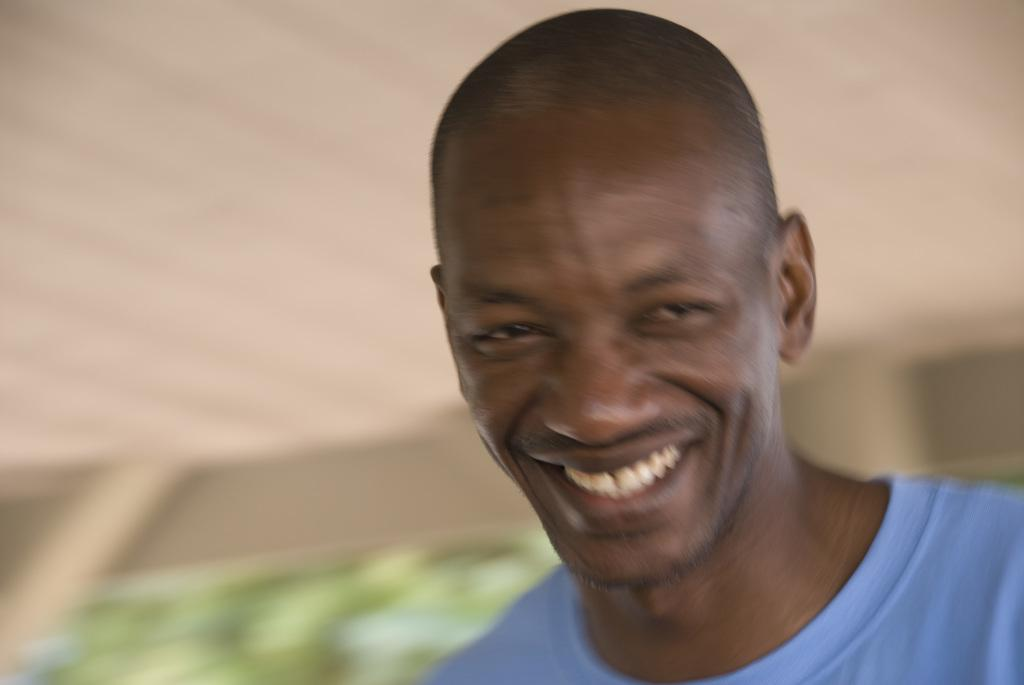Who or what is the main subject in the image? There is a person in the image. What is the person wearing? The person is wearing a blue dress. Can you describe the background of the image? The background of the image includes cream and green colors. What type of card is the person holding in the image? There is no card present in the image. Can you see any wings on the person in the image? There are no wings visible on the person in the image. 